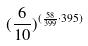Convert formula to latex. <formula><loc_0><loc_0><loc_500><loc_500>( \frac { 6 } { 1 0 } ) ^ { ( \frac { 5 8 } { 3 9 9 } \cdot 3 9 5 ) }</formula> 